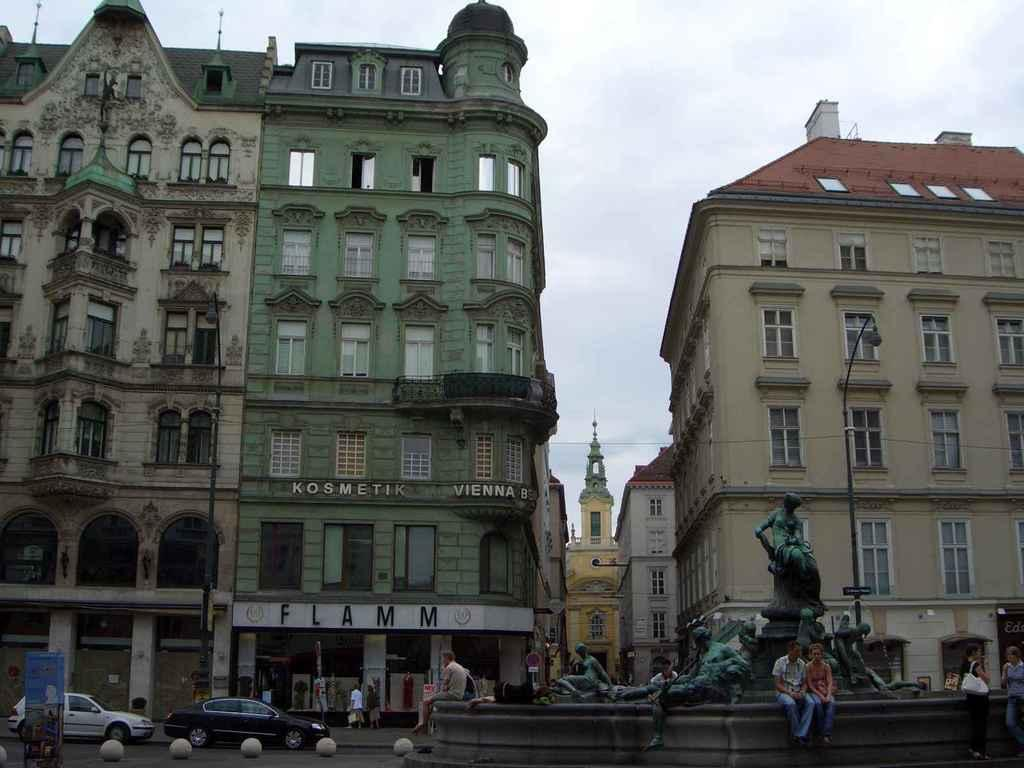Provide a one-sentence caption for the provided image. People in Vienna surround a statue with a building in the background that says FLAMM. 